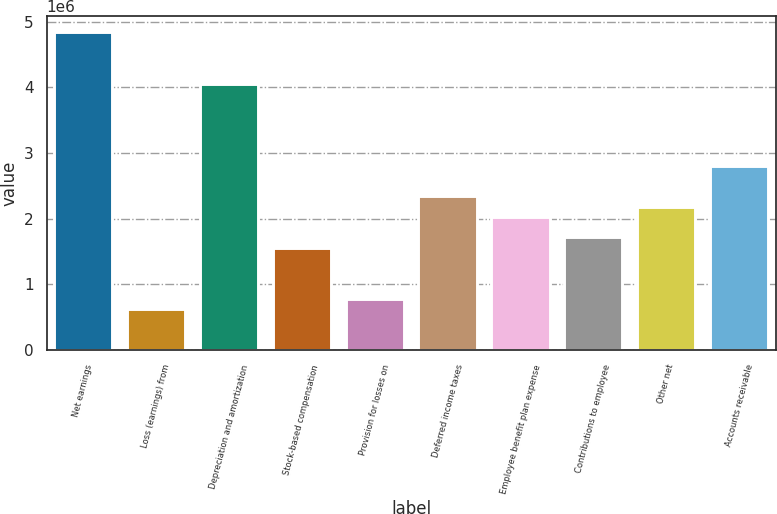<chart> <loc_0><loc_0><loc_500><loc_500><bar_chart><fcel>Net earnings<fcel>Loss (earnings) from<fcel>Depreciation and amortization<fcel>Stock-based compensation<fcel>Provision for losses on<fcel>Deferred income taxes<fcel>Employee benefit plan expense<fcel>Contributions to employee<fcel>Other net<fcel>Accounts receivable<nl><fcel>4.84051e+06<fcel>624944<fcel>4.05985e+06<fcel>1.56174e+06<fcel>781076<fcel>2.3424e+06<fcel>2.03013e+06<fcel>1.71787e+06<fcel>2.18627e+06<fcel>2.81079e+06<nl></chart> 